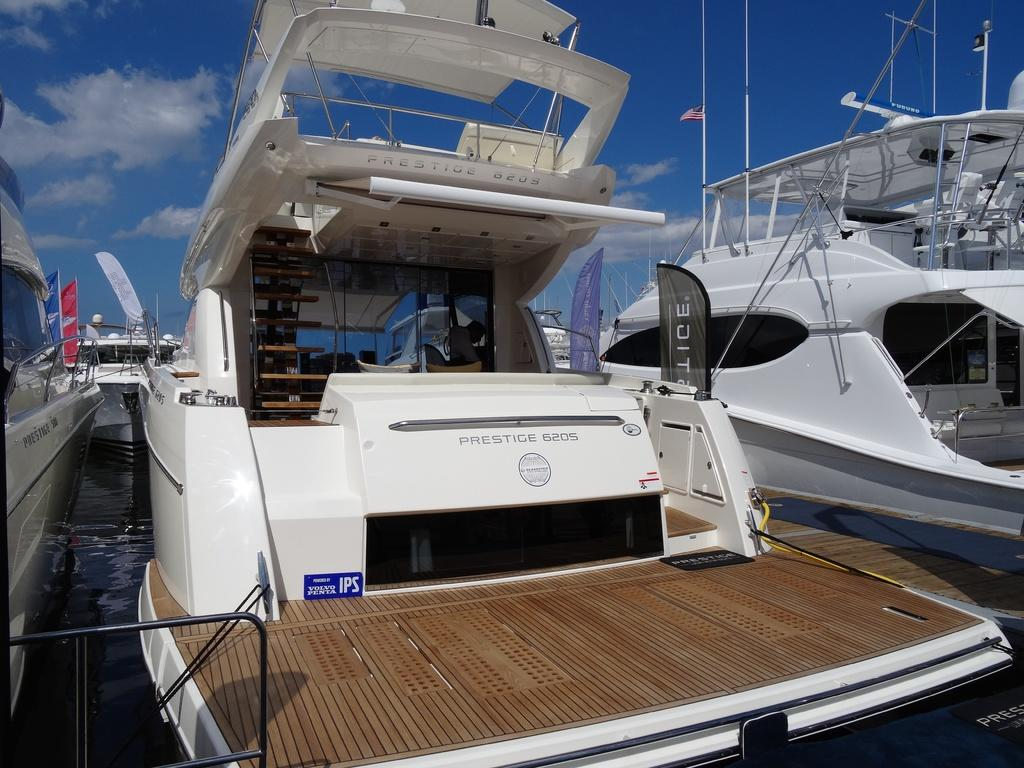What type of vehicles are in the image? There are boats in the image. Where are the boats located? The boats are on the water. What can be seen in the background of the image? There is a sky visible in the background of the image. What type of poison is being used by the band during their meeting in the image? There is no band or meeting present in the image, and therefore no poison can be observed. 